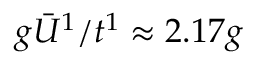<formula> <loc_0><loc_0><loc_500><loc_500>g \bar { U } ^ { 1 } / t ^ { 1 } \approx 2 . 1 7 g</formula> 